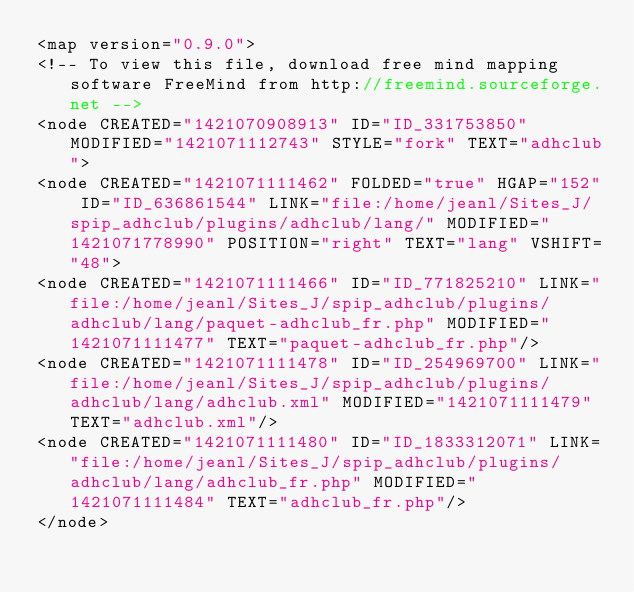<code> <loc_0><loc_0><loc_500><loc_500><_ObjectiveC_><map version="0.9.0">
<!-- To view this file, download free mind mapping software FreeMind from http://freemind.sourceforge.net -->
<node CREATED="1421070908913" ID="ID_331753850" MODIFIED="1421071112743" STYLE="fork" TEXT="adhclub">
<node CREATED="1421071111462" FOLDED="true" HGAP="152" ID="ID_636861544" LINK="file:/home/jeanl/Sites_J/spip_adhclub/plugins/adhclub/lang/" MODIFIED="1421071778990" POSITION="right" TEXT="lang" VSHIFT="48">
<node CREATED="1421071111466" ID="ID_771825210" LINK="file:/home/jeanl/Sites_J/spip_adhclub/plugins/adhclub/lang/paquet-adhclub_fr.php" MODIFIED="1421071111477" TEXT="paquet-adhclub_fr.php"/>
<node CREATED="1421071111478" ID="ID_254969700" LINK="file:/home/jeanl/Sites_J/spip_adhclub/plugins/adhclub/lang/adhclub.xml" MODIFIED="1421071111479" TEXT="adhclub.xml"/>
<node CREATED="1421071111480" ID="ID_1833312071" LINK="file:/home/jeanl/Sites_J/spip_adhclub/plugins/adhclub/lang/adhclub_fr.php" MODIFIED="1421071111484" TEXT="adhclub_fr.php"/>
</node></code> 